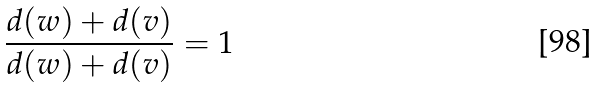<formula> <loc_0><loc_0><loc_500><loc_500>\frac { d ( w ) + d ( v ) } { d ( w ) + d ( v ) } = 1</formula> 